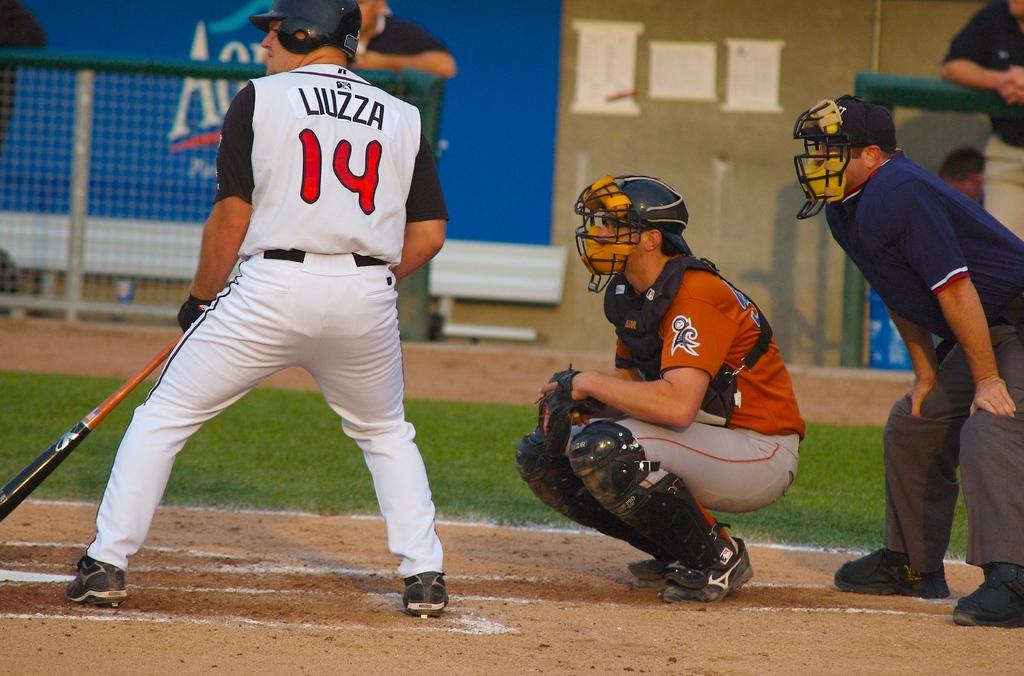Provide a one-sentence caption for the provided image. Baseball player at home plate that is batting with the name Liuzza # 14. 